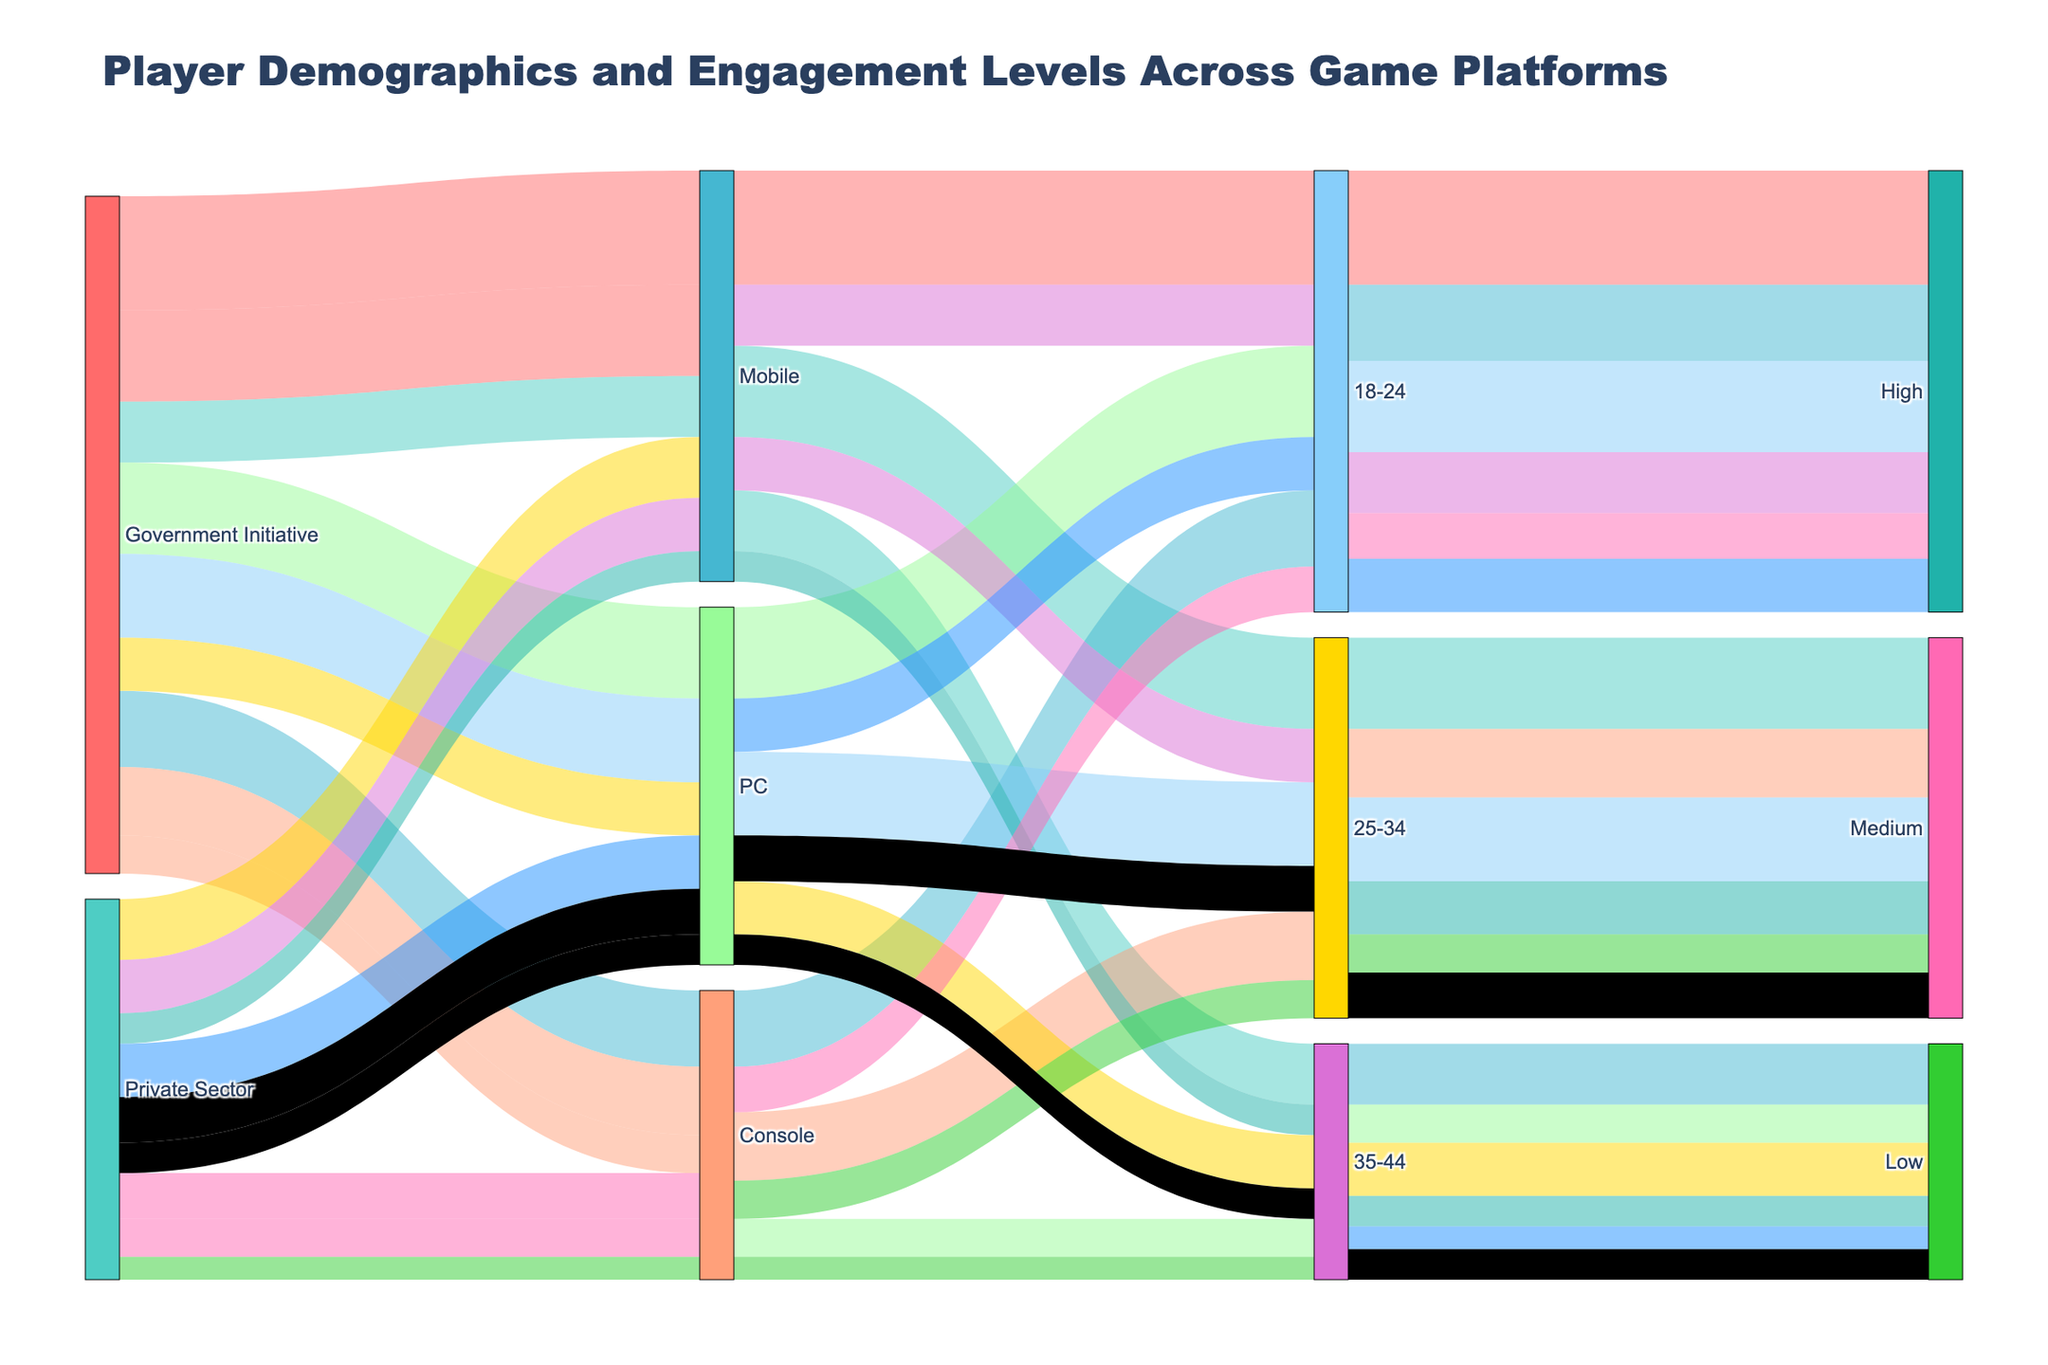What's the title of the figure? The title of the figure is displayed at the top of the plot. It provides a summary of what information the figure represents.
Answer: Player Demographics and Engagement Levels Across Game Platforms What age group has the highest engagement level on PC platforms supported by government initiatives? Locate the segments corresponding to PC platforms and government initiatives, then find the 18-24 age group and its associated engagement level.
Answer: 18-24 How many players aged 25-34 use mobile platforms supported by government initiatives? Trace the flow from government initiatives to mobile platforms, then find the segment for the 25-34 age group and check the number of players associated with it.
Answer: 12000 Compare the number of players in the 18-24 age group with high engagement on government-supported mobile and console platforms. Which platform has more players, and by how much? Identify and compare the number of players in the 18-24 age group with high engagement on both mobile and console platforms supported by government initiatives. Subtract the lower number from the higher number to find the difference.
Answer: Mobile has 5000 more players Considering all platforms, which age group has the least number of players with low engagement levels in government-supported games? Summarize the number of low engagement players across all platforms for each age group in government-supported games, then identify the age group with the least total players.
Answer: 35-44 How does the number of high engagement players aged 18-24 on PC platforms supported by the private sector compare to government initiatives? Locate the flow for 18-24 high engagement on PC for both the private sector and government initiatives, then compare the two numbers.
Answer: Government initiatives have 5000 more players What is the total number of medium engagement players aged 25-34 on all platforms supported by the private sector? Sum up the number of 25-34 medium engagement players across mobile, console, and PC platforms supported by the private sector.
Answer: 18000 Which platform has the highest number of players aged 35-44 with low engagement under government initiatives? Compare the number of 35-44 low engagement players across different platforms (mobile, console, PC) under government initiatives and find the platform with the highest total.
Answer: Mobile Among platforms supported by government initiatives, which age group has the highest number of players on console platforms with medium engagement levels? Focus on console platforms and medium engagement levels, then identify which age group has the highest number of players.
Answer: 25-34 How does the color for high engagement levels differ from the color used for low engagement levels? Examine the segments and find the colors used to represent high and low engagement levels. Describe the difference.
Answer: High engagement is marked in pink and low engagement in blue 